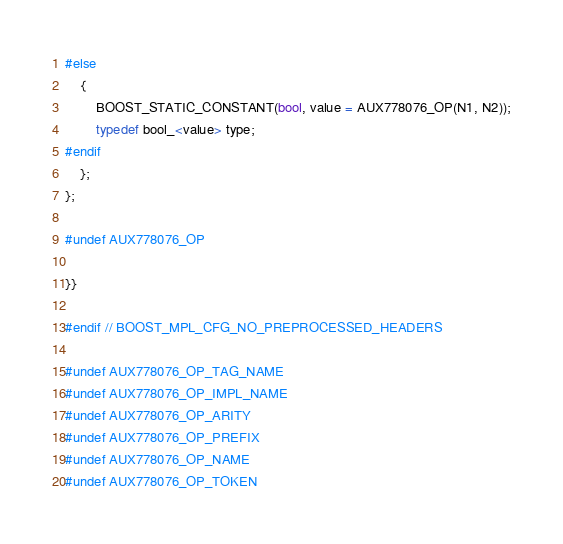Convert code to text. <code><loc_0><loc_0><loc_500><loc_500><_C++_>#else
    {
        BOOST_STATIC_CONSTANT(bool, value = AUX778076_OP(N1, N2));
        typedef bool_<value> type;
#endif
    };
};

#undef AUX778076_OP

}}

#endif // BOOST_MPL_CFG_NO_PREPROCESSED_HEADERS

#undef AUX778076_OP_TAG_NAME
#undef AUX778076_OP_IMPL_NAME
#undef AUX778076_OP_ARITY
#undef AUX778076_OP_PREFIX
#undef AUX778076_OP_NAME
#undef AUX778076_OP_TOKEN
</code> 